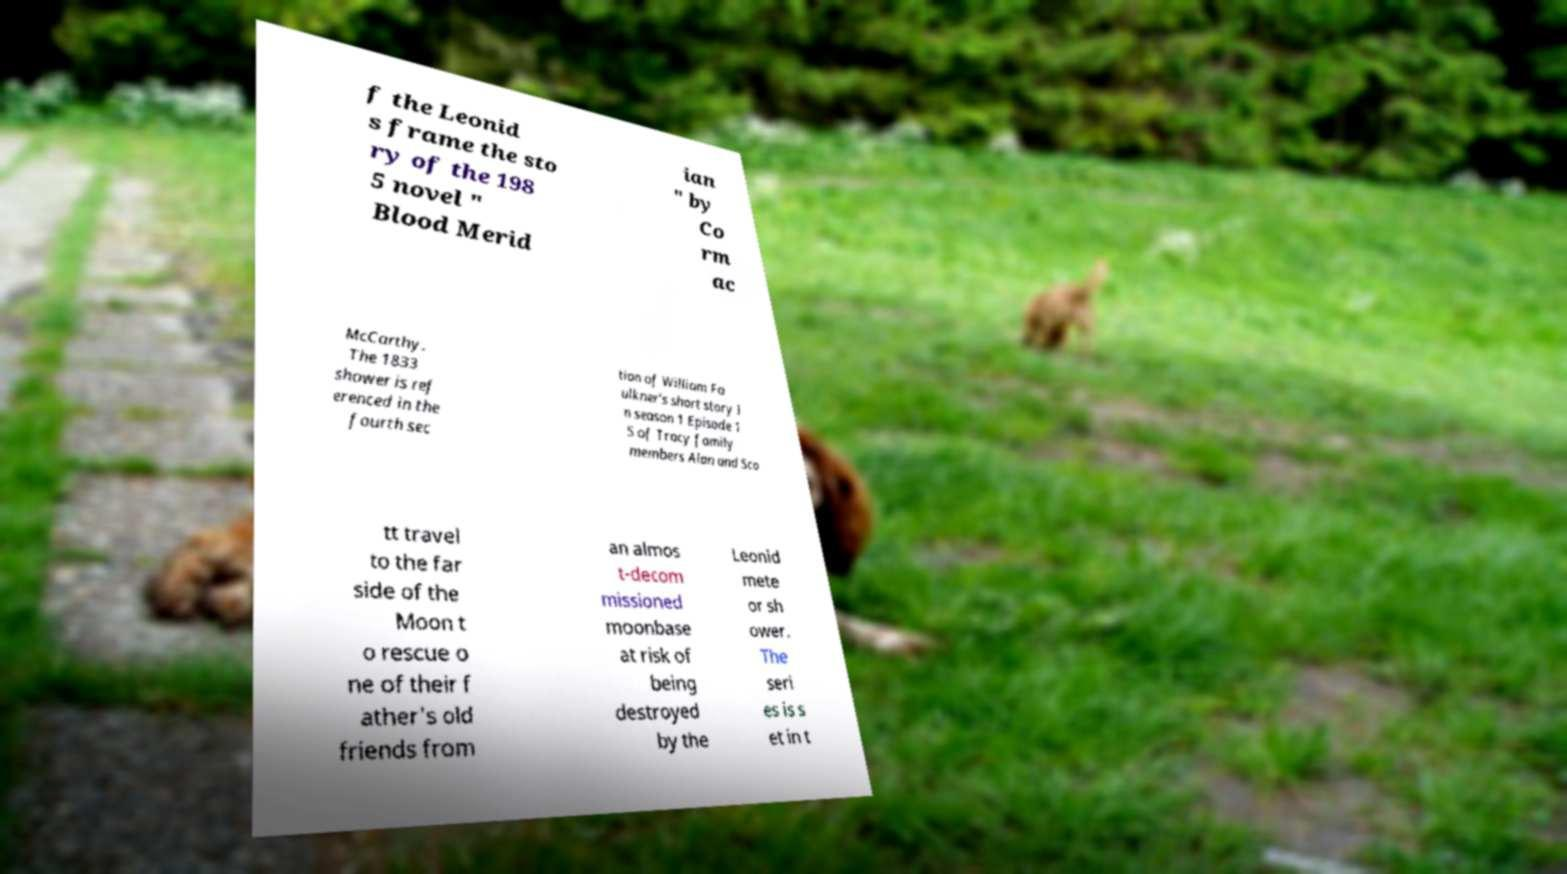What messages or text are displayed in this image? I need them in a readable, typed format. f the Leonid s frame the sto ry of the 198 5 novel " Blood Merid ian " by Co rm ac McCarthy. The 1833 shower is ref erenced in the fourth sec tion of William Fa ulkner's short story I n season 1 Episode 1 5 of Tracy family members Alan and Sco tt travel to the far side of the Moon t o rescue o ne of their f ather's old friends from an almos t-decom missioned moonbase at risk of being destroyed by the Leonid mete or sh ower. The seri es is s et in t 